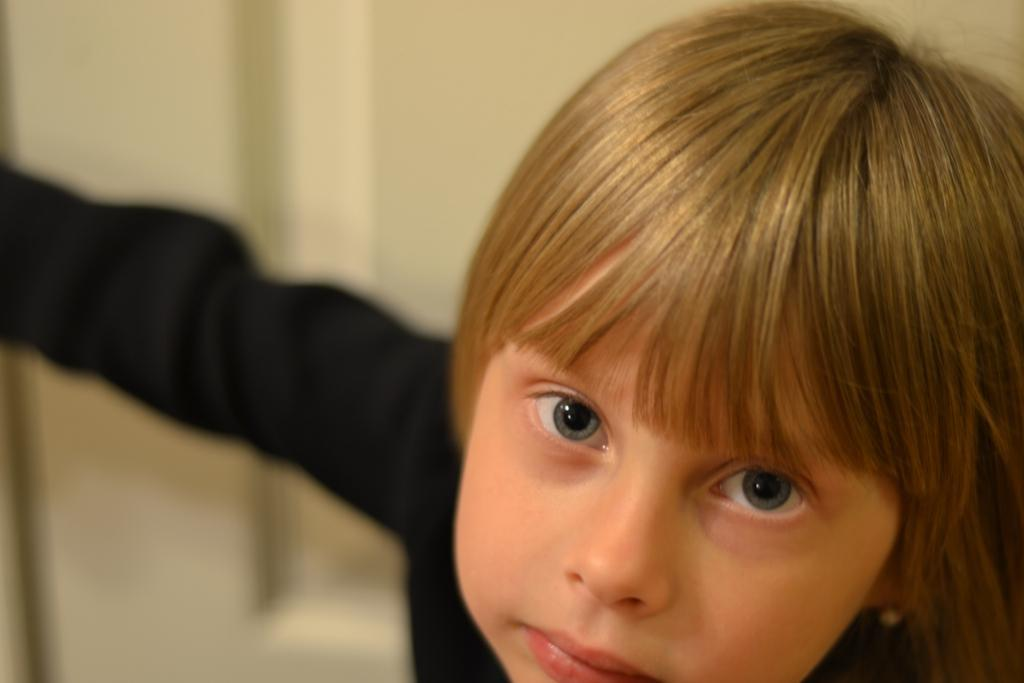Who is the main subject in the image? There is a boy in the image. What is the boy wearing? The boy is wearing a black dress. Can you describe the background of the image? The background of the image is blurred. What invention does the boy suggest in the image? There is no indication in the image that the boy is suggesting any invention. 